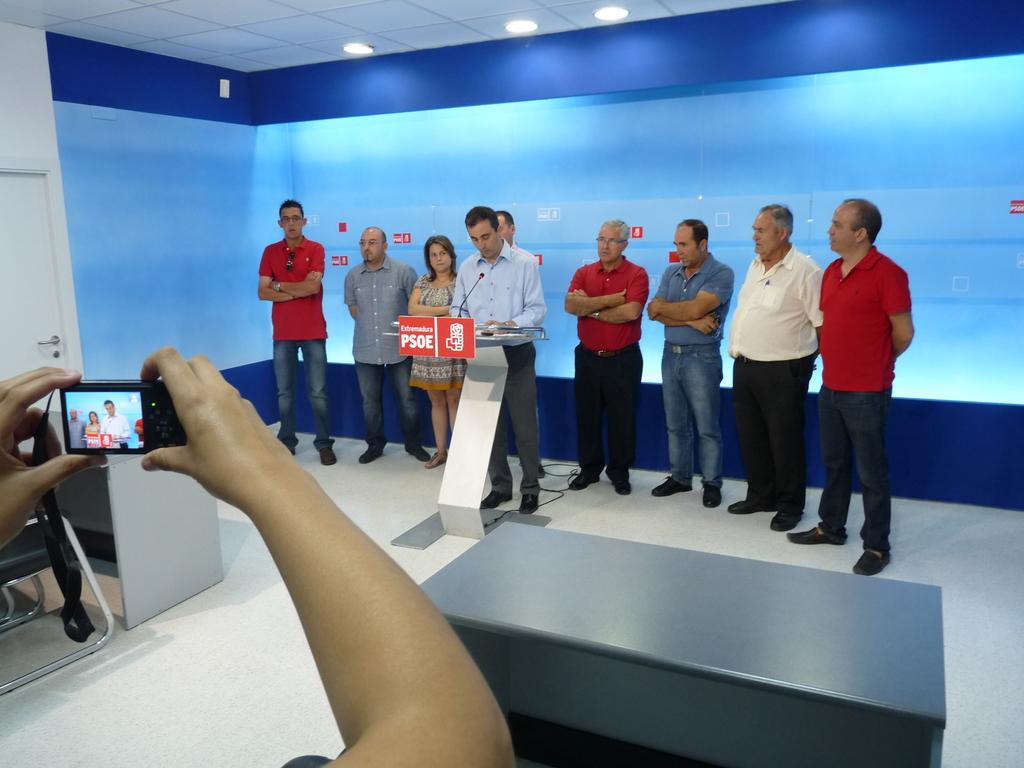What is the general arrangement of the people in the image? There is a group of people standing, with a man in front of them. What object is the man in front of the group using? The man is using a microphone. What is on the podium in front of the man? There is a board on the podium. What is being used to capture the event in the image? There is a camera being held by someone. What can be seen in the background of the image? There is a wall, a screen, and lights in the background. What type of twig is being used as a prop by the man in the image? There is no twig present in the image. How does the camera look at the people in the image? The camera does not have a face or the ability to look; it is being held by someone to capture the event. 